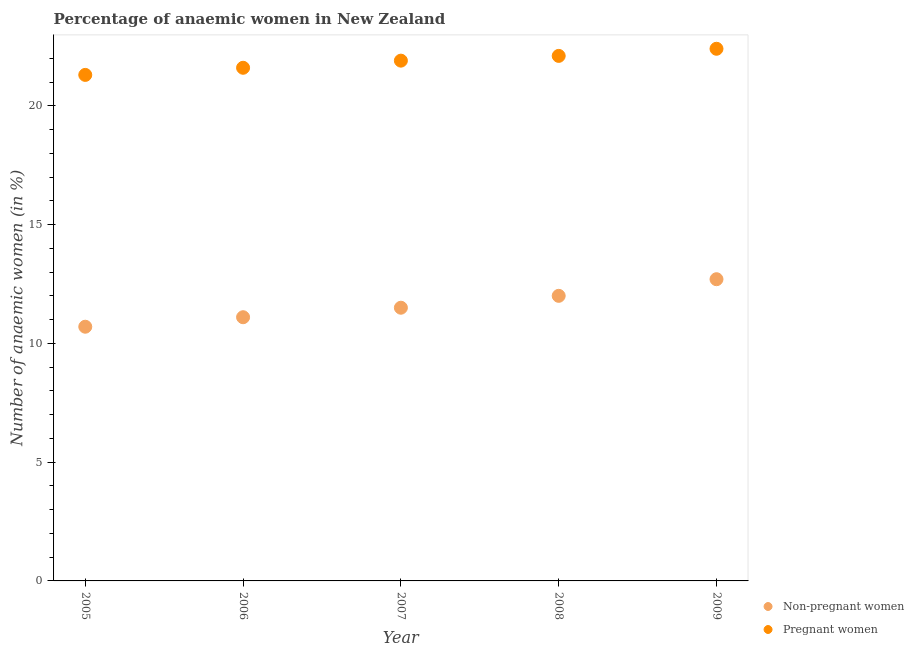Across all years, what is the maximum percentage of pregnant anaemic women?
Your response must be concise. 22.4. Across all years, what is the minimum percentage of non-pregnant anaemic women?
Your answer should be compact. 10.7. In which year was the percentage of pregnant anaemic women maximum?
Give a very brief answer. 2009. What is the total percentage of non-pregnant anaemic women in the graph?
Offer a terse response. 58. What is the difference between the percentage of non-pregnant anaemic women in 2006 and that in 2008?
Ensure brevity in your answer.  -0.9. What is the difference between the percentage of non-pregnant anaemic women in 2006 and the percentage of pregnant anaemic women in 2009?
Your answer should be very brief. -11.3. What is the average percentage of non-pregnant anaemic women per year?
Your response must be concise. 11.6. In the year 2007, what is the difference between the percentage of non-pregnant anaemic women and percentage of pregnant anaemic women?
Your answer should be very brief. -10.4. What is the ratio of the percentage of non-pregnant anaemic women in 2006 to that in 2008?
Your response must be concise. 0.92. Is the percentage of pregnant anaemic women in 2006 less than that in 2008?
Offer a very short reply. Yes. Is the difference between the percentage of non-pregnant anaemic women in 2006 and 2009 greater than the difference between the percentage of pregnant anaemic women in 2006 and 2009?
Make the answer very short. No. What is the difference between the highest and the second highest percentage of pregnant anaemic women?
Your response must be concise. 0.3. What is the difference between the highest and the lowest percentage of pregnant anaemic women?
Provide a short and direct response. 1.1. What is the difference between two consecutive major ticks on the Y-axis?
Give a very brief answer. 5. Are the values on the major ticks of Y-axis written in scientific E-notation?
Provide a succinct answer. No. Does the graph contain any zero values?
Your answer should be very brief. No. How many legend labels are there?
Your response must be concise. 2. How are the legend labels stacked?
Make the answer very short. Vertical. What is the title of the graph?
Your answer should be compact. Percentage of anaemic women in New Zealand. What is the label or title of the Y-axis?
Provide a short and direct response. Number of anaemic women (in %). What is the Number of anaemic women (in %) in Pregnant women in 2005?
Offer a terse response. 21.3. What is the Number of anaemic women (in %) in Non-pregnant women in 2006?
Offer a very short reply. 11.1. What is the Number of anaemic women (in %) of Pregnant women in 2006?
Your response must be concise. 21.6. What is the Number of anaemic women (in %) of Pregnant women in 2007?
Give a very brief answer. 21.9. What is the Number of anaemic women (in %) in Non-pregnant women in 2008?
Your answer should be very brief. 12. What is the Number of anaemic women (in %) of Pregnant women in 2008?
Provide a succinct answer. 22.1. What is the Number of anaemic women (in %) of Non-pregnant women in 2009?
Keep it short and to the point. 12.7. What is the Number of anaemic women (in %) in Pregnant women in 2009?
Keep it short and to the point. 22.4. Across all years, what is the maximum Number of anaemic women (in %) of Pregnant women?
Give a very brief answer. 22.4. Across all years, what is the minimum Number of anaemic women (in %) of Pregnant women?
Offer a terse response. 21.3. What is the total Number of anaemic women (in %) in Pregnant women in the graph?
Provide a short and direct response. 109.3. What is the difference between the Number of anaemic women (in %) of Non-pregnant women in 2005 and that in 2006?
Offer a very short reply. -0.4. What is the difference between the Number of anaemic women (in %) of Non-pregnant women in 2005 and that in 2008?
Keep it short and to the point. -1.3. What is the difference between the Number of anaemic women (in %) in Non-pregnant women in 2006 and that in 2007?
Keep it short and to the point. -0.4. What is the difference between the Number of anaemic women (in %) in Pregnant women in 2006 and that in 2007?
Your answer should be very brief. -0.3. What is the difference between the Number of anaemic women (in %) of Pregnant women in 2006 and that in 2008?
Ensure brevity in your answer.  -0.5. What is the difference between the Number of anaemic women (in %) in Non-pregnant women in 2006 and that in 2009?
Offer a terse response. -1.6. What is the difference between the Number of anaemic women (in %) in Non-pregnant women in 2007 and that in 2008?
Ensure brevity in your answer.  -0.5. What is the difference between the Number of anaemic women (in %) in Pregnant women in 2007 and that in 2008?
Make the answer very short. -0.2. What is the difference between the Number of anaemic women (in %) of Non-pregnant women in 2005 and the Number of anaemic women (in %) of Pregnant women in 2008?
Offer a terse response. -11.4. What is the difference between the Number of anaemic women (in %) of Non-pregnant women in 2006 and the Number of anaemic women (in %) of Pregnant women in 2008?
Provide a succinct answer. -11. What is the difference between the Number of anaemic women (in %) of Non-pregnant women in 2006 and the Number of anaemic women (in %) of Pregnant women in 2009?
Offer a very short reply. -11.3. What is the difference between the Number of anaemic women (in %) of Non-pregnant women in 2007 and the Number of anaemic women (in %) of Pregnant women in 2008?
Offer a terse response. -10.6. What is the difference between the Number of anaemic women (in %) in Non-pregnant women in 2007 and the Number of anaemic women (in %) in Pregnant women in 2009?
Your answer should be very brief. -10.9. What is the difference between the Number of anaemic women (in %) of Non-pregnant women in 2008 and the Number of anaemic women (in %) of Pregnant women in 2009?
Provide a short and direct response. -10.4. What is the average Number of anaemic women (in %) in Non-pregnant women per year?
Provide a short and direct response. 11.6. What is the average Number of anaemic women (in %) in Pregnant women per year?
Give a very brief answer. 21.86. In the year 2007, what is the difference between the Number of anaemic women (in %) of Non-pregnant women and Number of anaemic women (in %) of Pregnant women?
Your answer should be very brief. -10.4. In the year 2009, what is the difference between the Number of anaemic women (in %) in Non-pregnant women and Number of anaemic women (in %) in Pregnant women?
Offer a terse response. -9.7. What is the ratio of the Number of anaemic women (in %) of Pregnant women in 2005 to that in 2006?
Make the answer very short. 0.99. What is the ratio of the Number of anaemic women (in %) in Non-pregnant women in 2005 to that in 2007?
Make the answer very short. 0.93. What is the ratio of the Number of anaemic women (in %) in Pregnant women in 2005 to that in 2007?
Give a very brief answer. 0.97. What is the ratio of the Number of anaemic women (in %) in Non-pregnant women in 2005 to that in 2008?
Give a very brief answer. 0.89. What is the ratio of the Number of anaemic women (in %) in Pregnant women in 2005 to that in 2008?
Your response must be concise. 0.96. What is the ratio of the Number of anaemic women (in %) in Non-pregnant women in 2005 to that in 2009?
Make the answer very short. 0.84. What is the ratio of the Number of anaemic women (in %) in Pregnant women in 2005 to that in 2009?
Give a very brief answer. 0.95. What is the ratio of the Number of anaemic women (in %) of Non-pregnant women in 2006 to that in 2007?
Your answer should be very brief. 0.97. What is the ratio of the Number of anaemic women (in %) of Pregnant women in 2006 to that in 2007?
Make the answer very short. 0.99. What is the ratio of the Number of anaemic women (in %) in Non-pregnant women in 2006 to that in 2008?
Your response must be concise. 0.93. What is the ratio of the Number of anaemic women (in %) of Pregnant women in 2006 to that in 2008?
Provide a short and direct response. 0.98. What is the ratio of the Number of anaemic women (in %) of Non-pregnant women in 2006 to that in 2009?
Offer a terse response. 0.87. What is the ratio of the Number of anaemic women (in %) of Non-pregnant women in 2007 to that in 2008?
Keep it short and to the point. 0.96. What is the ratio of the Number of anaemic women (in %) in Pregnant women in 2007 to that in 2008?
Provide a succinct answer. 0.99. What is the ratio of the Number of anaemic women (in %) of Non-pregnant women in 2007 to that in 2009?
Provide a short and direct response. 0.91. What is the ratio of the Number of anaemic women (in %) of Pregnant women in 2007 to that in 2009?
Provide a short and direct response. 0.98. What is the ratio of the Number of anaemic women (in %) in Non-pregnant women in 2008 to that in 2009?
Make the answer very short. 0.94. What is the ratio of the Number of anaemic women (in %) of Pregnant women in 2008 to that in 2009?
Your answer should be compact. 0.99. What is the difference between the highest and the second highest Number of anaemic women (in %) in Non-pregnant women?
Your answer should be compact. 0.7. What is the difference between the highest and the lowest Number of anaemic women (in %) of Non-pregnant women?
Provide a short and direct response. 2. 